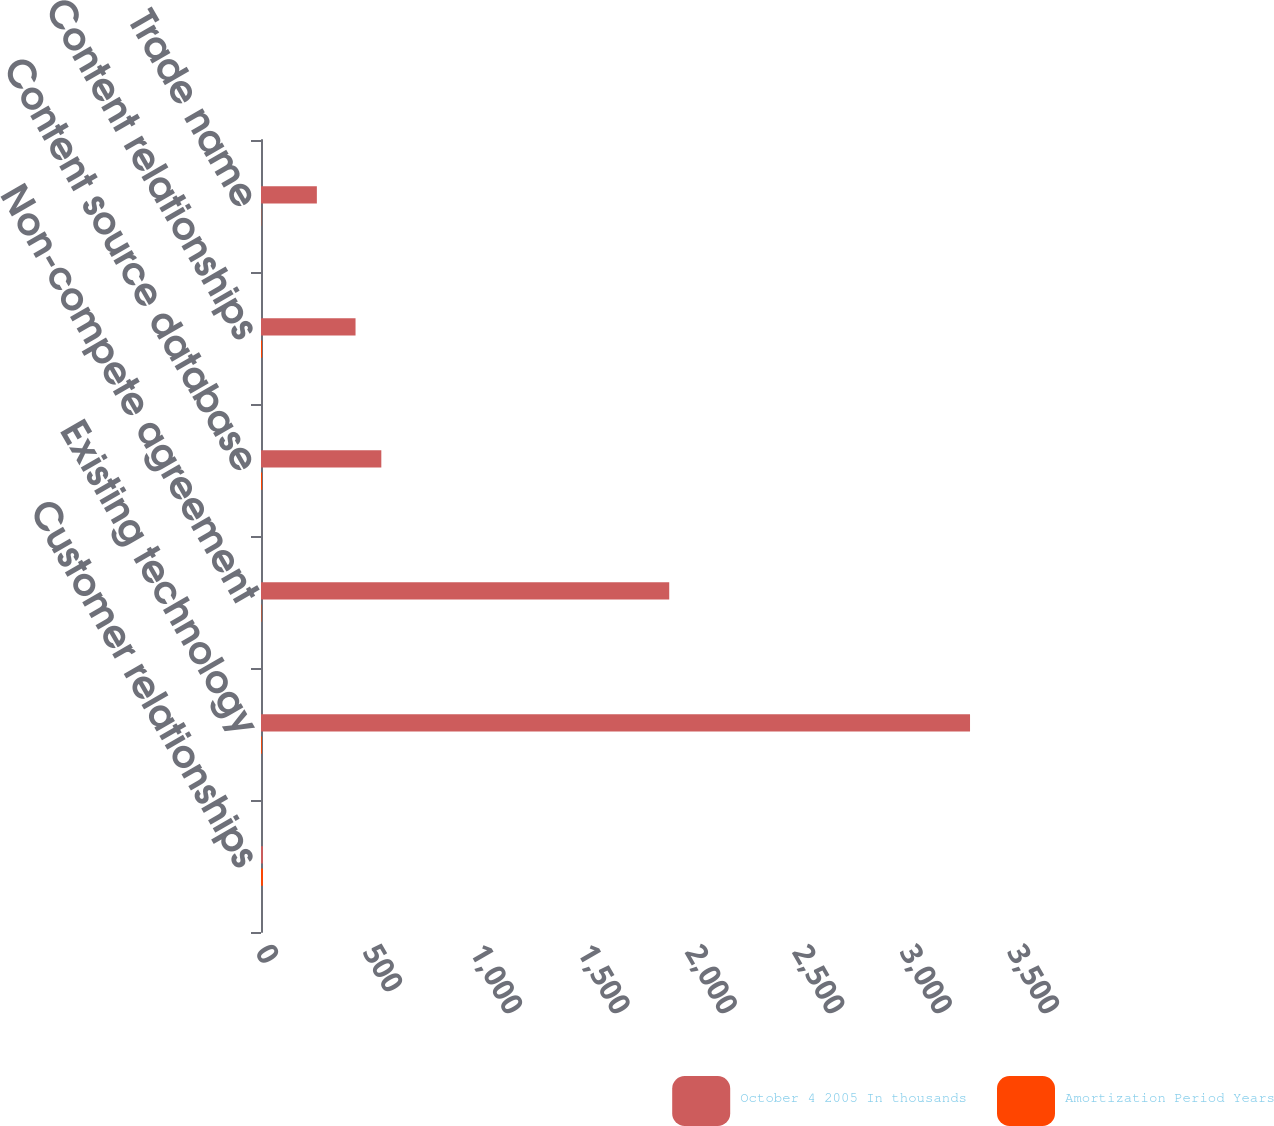Convert chart to OTSL. <chart><loc_0><loc_0><loc_500><loc_500><stacked_bar_chart><ecel><fcel>Customer relationships<fcel>Existing technology<fcel>Non-compete agreement<fcel>Content source database<fcel>Content relationships<fcel>Trade name<nl><fcel>October 4 2005 In thousands<fcel>9<fcel>3300<fcel>1900<fcel>560<fcel>440<fcel>260<nl><fcel>Amortization Period Years<fcel>9<fcel>4<fcel>2<fcel>5<fcel>5<fcel>1<nl></chart> 